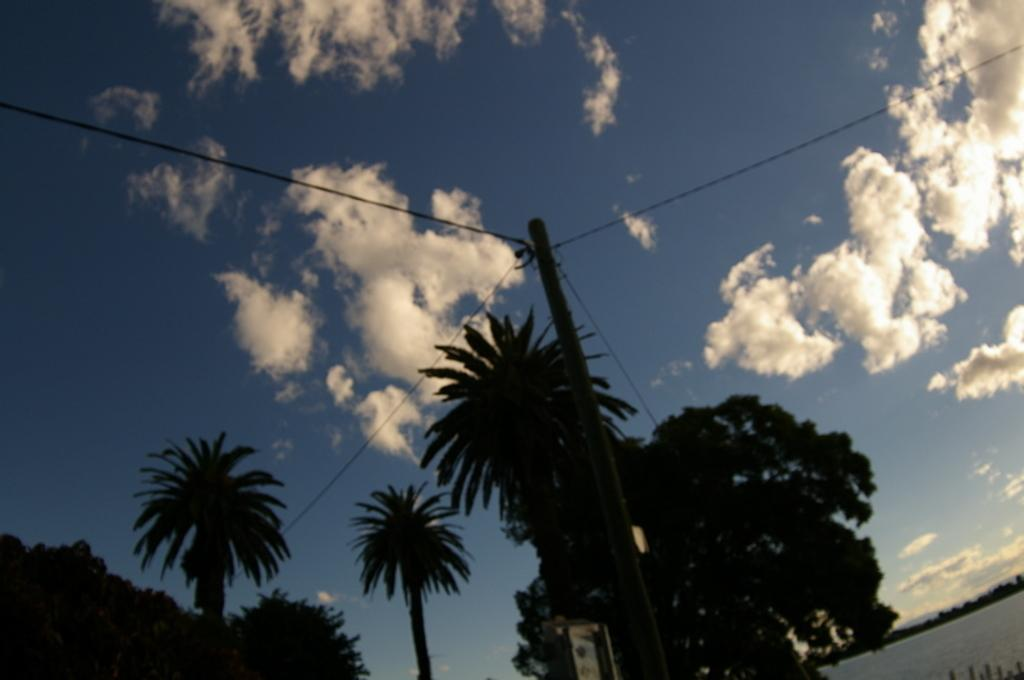What can be seen in the sky in the image? The sky with clouds is visible in the image. What type of structure is present in the image? There is an electric pole in the image. What is connected to the electric pole? Electric cables are present in the image. What type of vegetation is in the image? There are trees in the image. What natural element is visible in the image? There is water visible in the image. What type of kitty is swimming in the water in the image? There is no kitty present in the image, and therefore no such activity can be observed. What type of produce is growing on the electric pole in the image? There is no produce present in the image, as the electric pole is a man-made structure. 